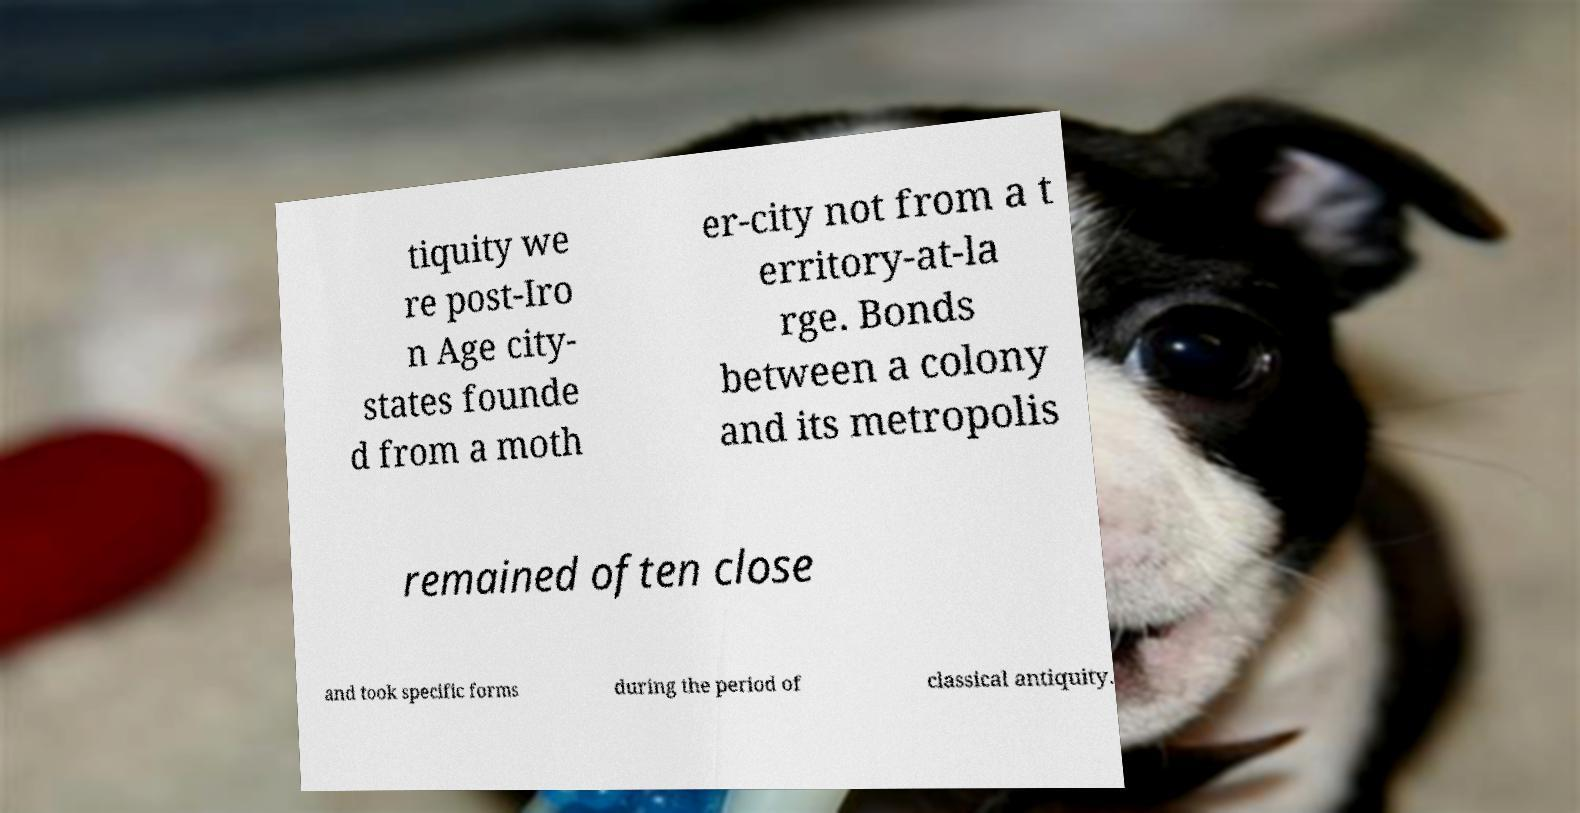For documentation purposes, I need the text within this image transcribed. Could you provide that? tiquity we re post-Iro n Age city- states founde d from a moth er-city not from a t erritory-at-la rge. Bonds between a colony and its metropolis remained often close and took specific forms during the period of classical antiquity. 